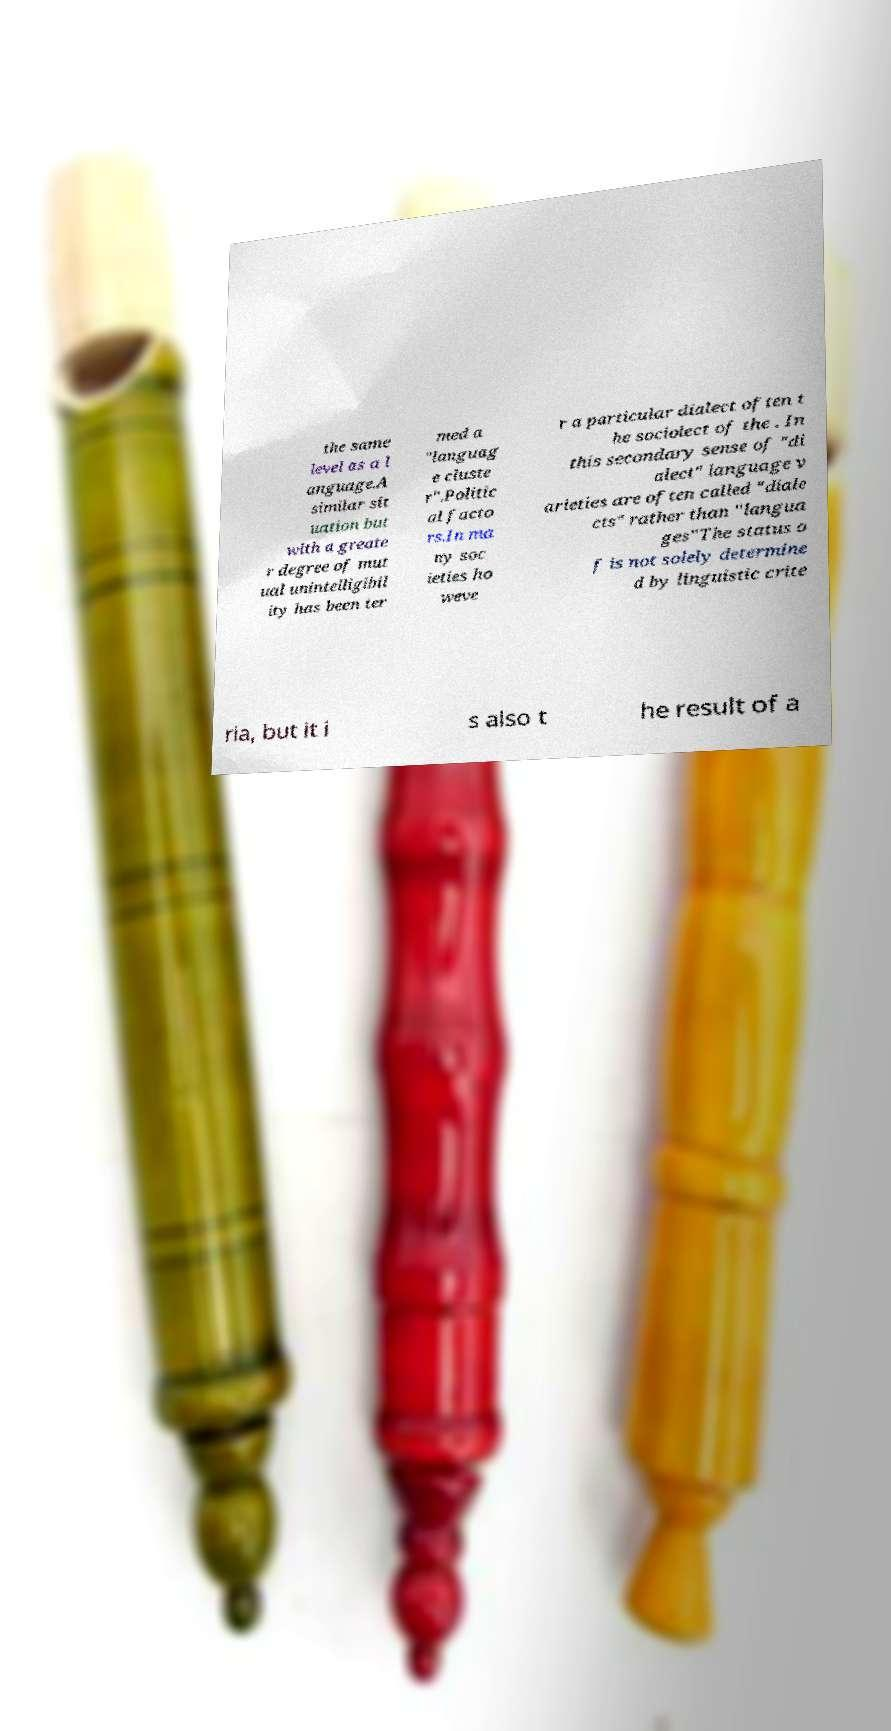Could you extract and type out the text from this image? the same level as a l anguage.A similar sit uation but with a greate r degree of mut ual unintelligibil ity has been ter med a "languag e cluste r".Politic al facto rs.In ma ny soc ieties ho weve r a particular dialect often t he sociolect of the . In this secondary sense of "di alect" language v arieties are often called "diale cts" rather than "langua ges"The status o f is not solely determine d by linguistic crite ria, but it i s also t he result of a 